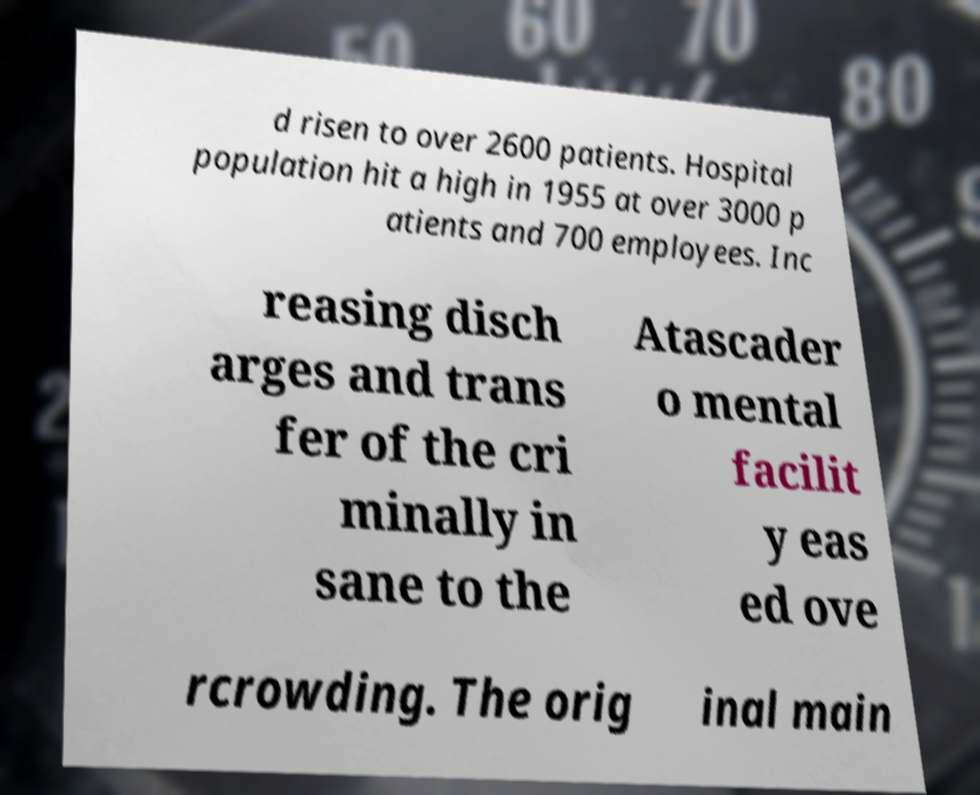Could you assist in decoding the text presented in this image and type it out clearly? d risen to over 2600 patients. Hospital population hit a high in 1955 at over 3000 p atients and 700 employees. Inc reasing disch arges and trans fer of the cri minally in sane to the Atascader o mental facilit y eas ed ove rcrowding. The orig inal main 